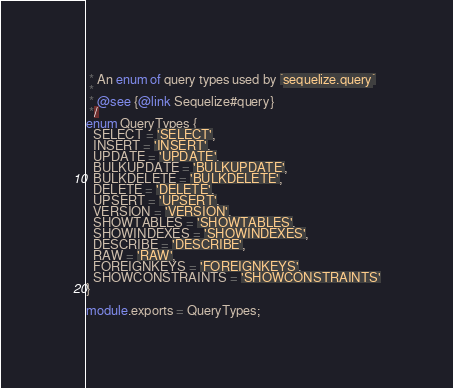<code> <loc_0><loc_0><loc_500><loc_500><_TypeScript_> * An enum of query types used by `sequelize.query`
 *
 * @see {@link Sequelize#query}
 */
enum QueryTypes {
  SELECT = 'SELECT',
  INSERT = 'INSERT',
  UPDATE = 'UPDATE',
  BULKUPDATE = 'BULKUPDATE',
  BULKDELETE = 'BULKDELETE',
  DELETE = 'DELETE',
  UPSERT = 'UPSERT',
  VERSION = 'VERSION',
  SHOWTABLES = 'SHOWTABLES',
  SHOWINDEXES = 'SHOWINDEXES',
  DESCRIBE = 'DESCRIBE',
  RAW = 'RAW',
  FOREIGNKEYS = 'FOREIGNKEYS',
  SHOWCONSTRAINTS = 'SHOWCONSTRAINTS'
}

module.exports = QueryTypes;
</code> 